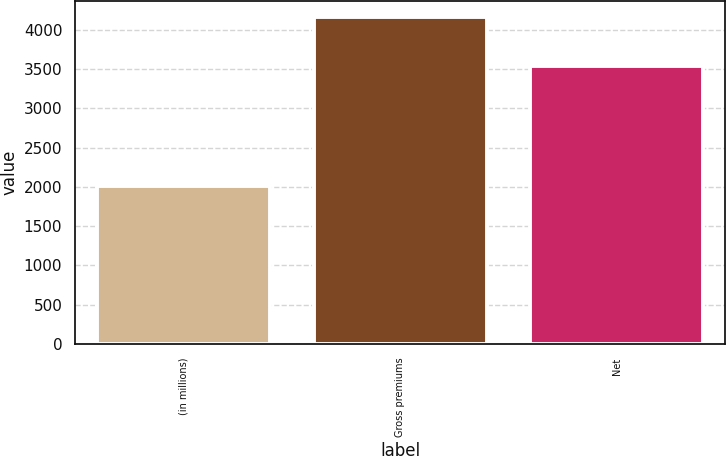Convert chart to OTSL. <chart><loc_0><loc_0><loc_500><loc_500><bar_chart><fcel>(in millions)<fcel>Gross premiums<fcel>Net<nl><fcel>2013<fcel>4155<fcel>3535<nl></chart> 